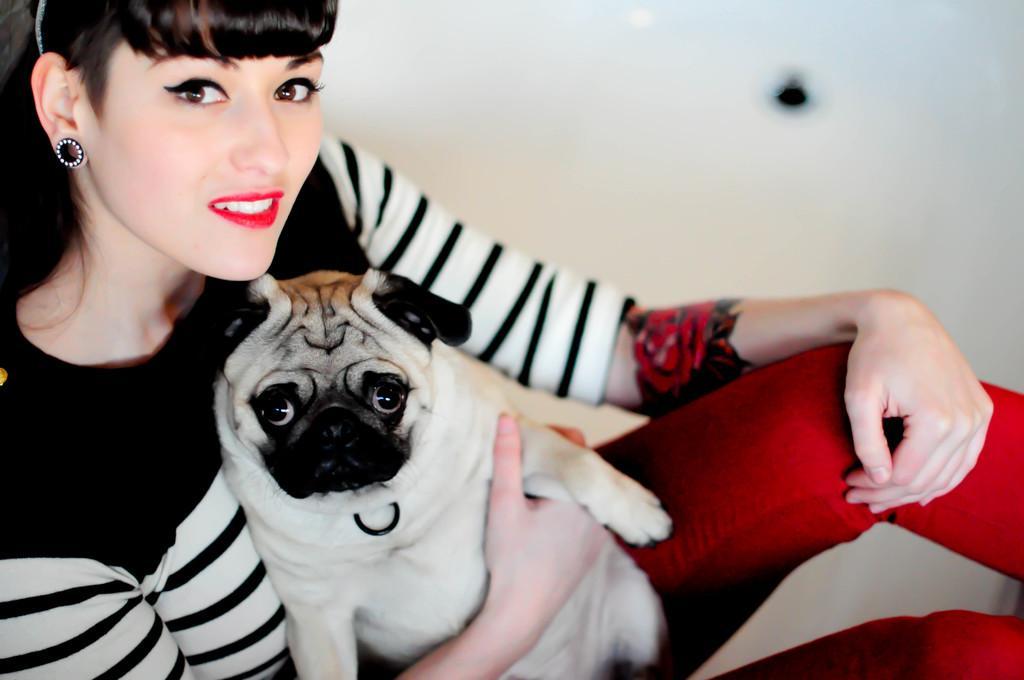Can you describe this image briefly? In the picture we can find a woman holding dog, she is smiling and she is wearing a white and black T-shirt. In the background we can find a wall. 